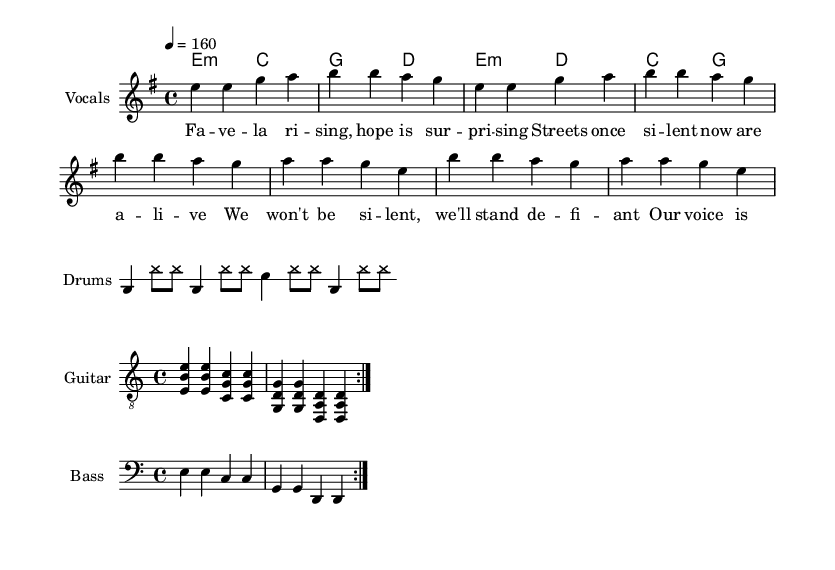What is the key signature of this music? The key signature is E minor, which includes one sharp (F#). This is indicated at the beginning of the music sheet.
Answer: E minor What is the time signature of this music? The time signature is 4/4, indicated at the start of the music, which means there are four beats in each measure and the quarter note gets one beat.
Answer: 4/4 What is the tempo marking of this piece? The tempo marking is 160 BPM (beats per minute), specified in the tempo notation, showing how fast the music should be played.
Answer: 160 What instrument is shown for the melody? The melody is written for vocals, as indicated by the instrument name in the staff header.
Answer: Vocals How many bars are in the verse section? The verse section has four bars (measures), as counted from the notation listed for the verse.
Answer: 4 What type of chords are used in the verse? The chords in the verse are minor and major chords, specifically E minor and C major, as indicated in the chord names section.
Answer: Minor and major What is the general theme of the lyrics? The general theme of the lyrics revolves around hope and resilience, addressing social issues and empowerment, indicated by the content of the words.
Answer: Hope and resilience 